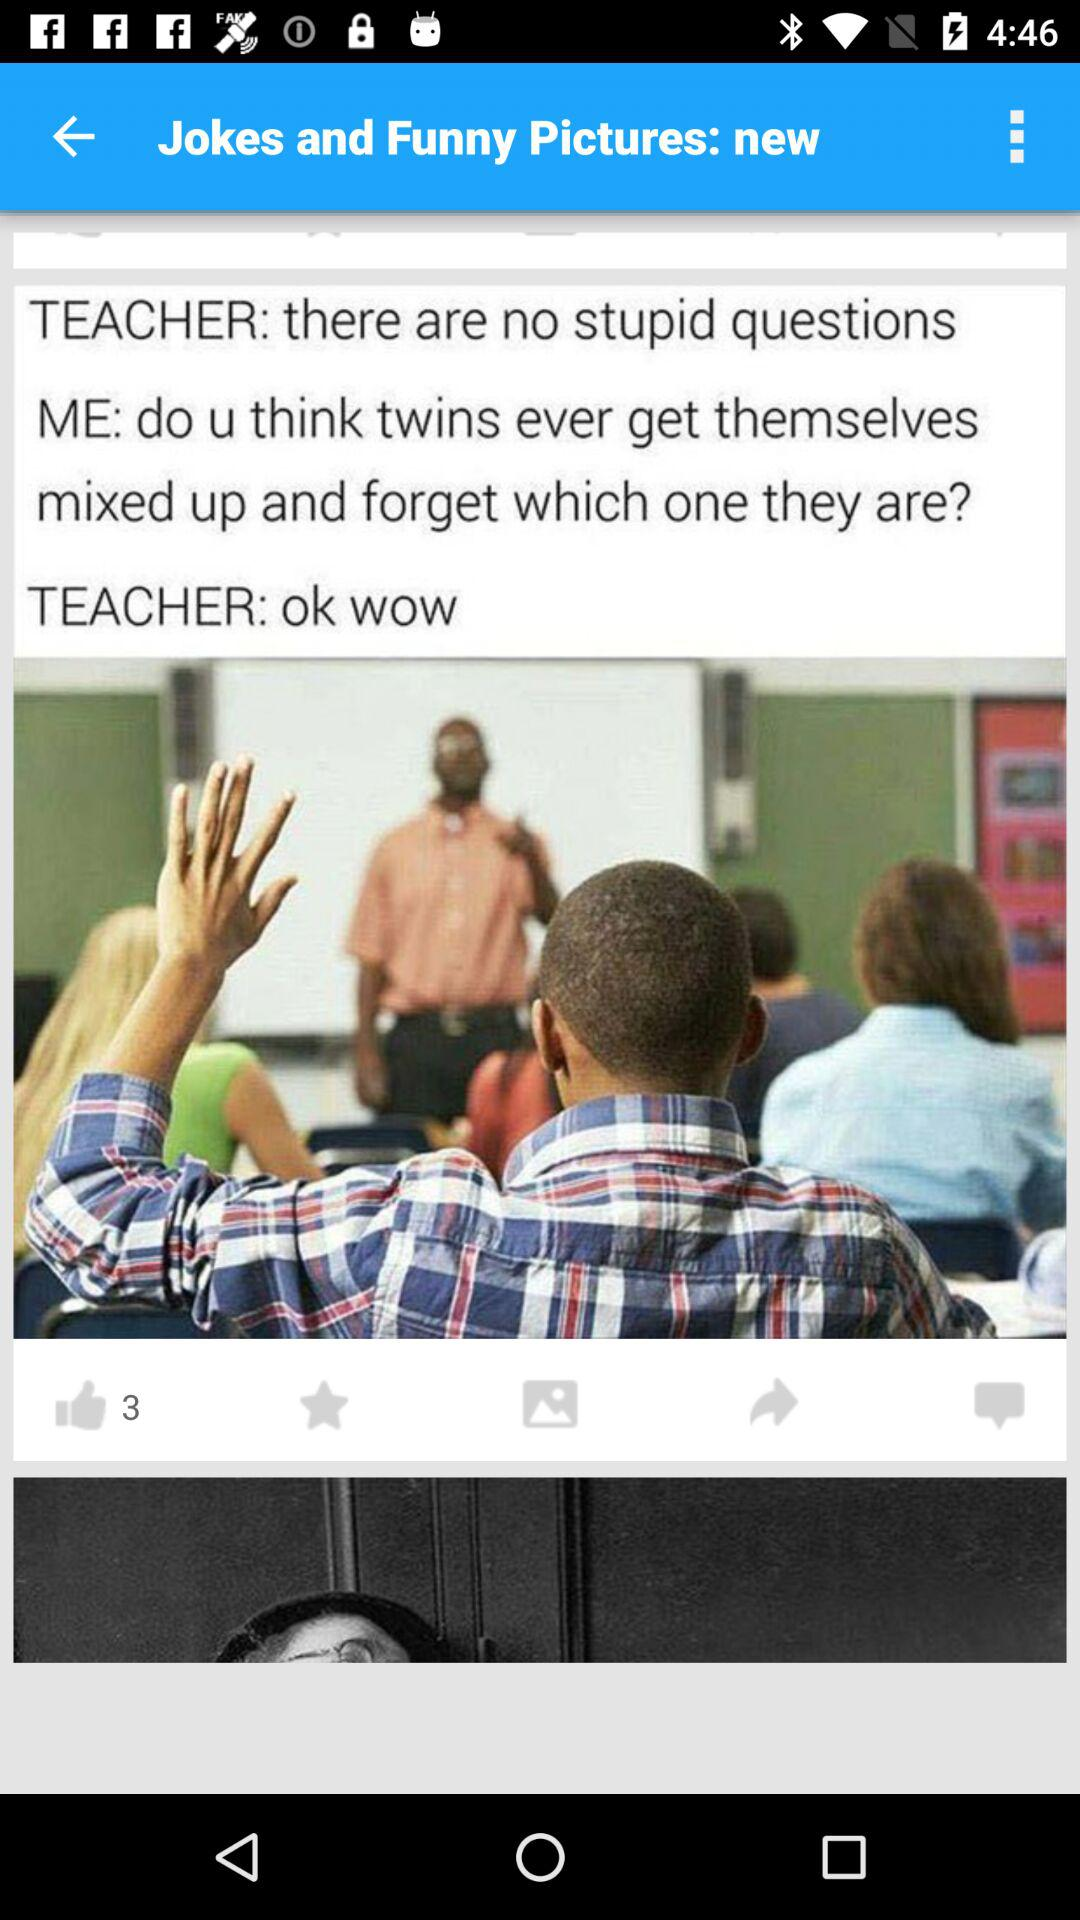How can the content be shared?
When the provided information is insufficient, respond with <no answer>. <no answer> 